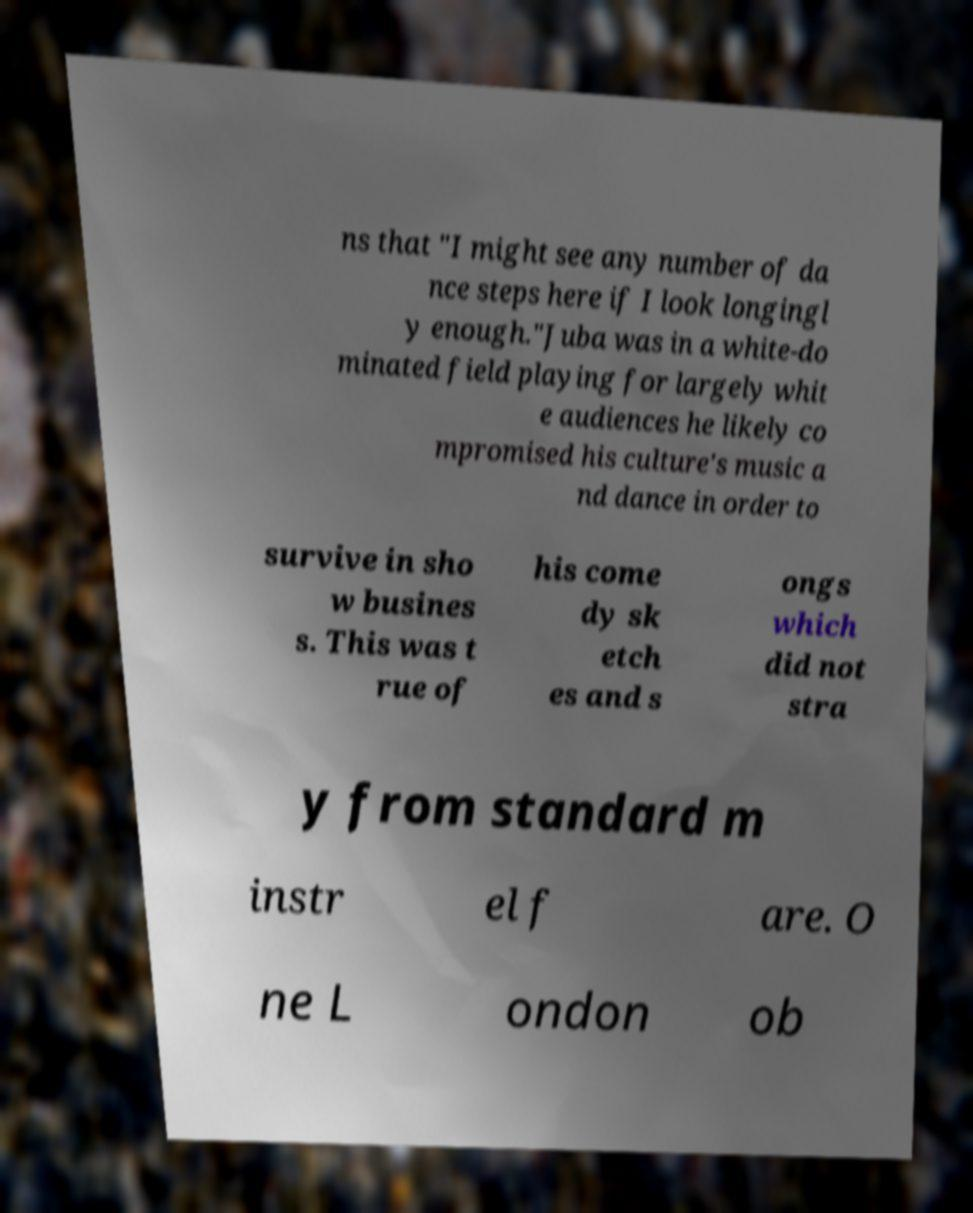For documentation purposes, I need the text within this image transcribed. Could you provide that? ns that "I might see any number of da nce steps here if I look longingl y enough."Juba was in a white-do minated field playing for largely whit e audiences he likely co mpromised his culture's music a nd dance in order to survive in sho w busines s. This was t rue of his come dy sk etch es and s ongs which did not stra y from standard m instr el f are. O ne L ondon ob 